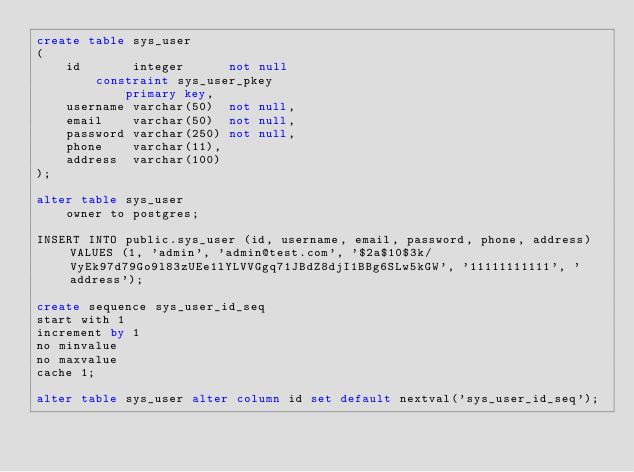Convert code to text. <code><loc_0><loc_0><loc_500><loc_500><_SQL_>create table sys_user
(
    id       integer      not null
        constraint sys_user_pkey
            primary key,
    username varchar(50)  not null,
    email    varchar(50)  not null,
    password varchar(250) not null,
    phone    varchar(11),
    address  varchar(100)
);

alter table sys_user
    owner to postgres;

INSERT INTO public.sys_user (id, username, email, password, phone, address) VALUES (1, 'admin', 'admin@test.com', '$2a$10$3k/VyEk97d79Go9l83zUEe1lYLVVGgq71JBdZ8djI1BBg6SLw5kGW', '11111111111', 'address');

create sequence sys_user_id_seq
start with 1
increment by 1
no minvalue
no maxvalue
cache 1;

alter table sys_user alter column id set default nextval('sys_user_id_seq');</code> 